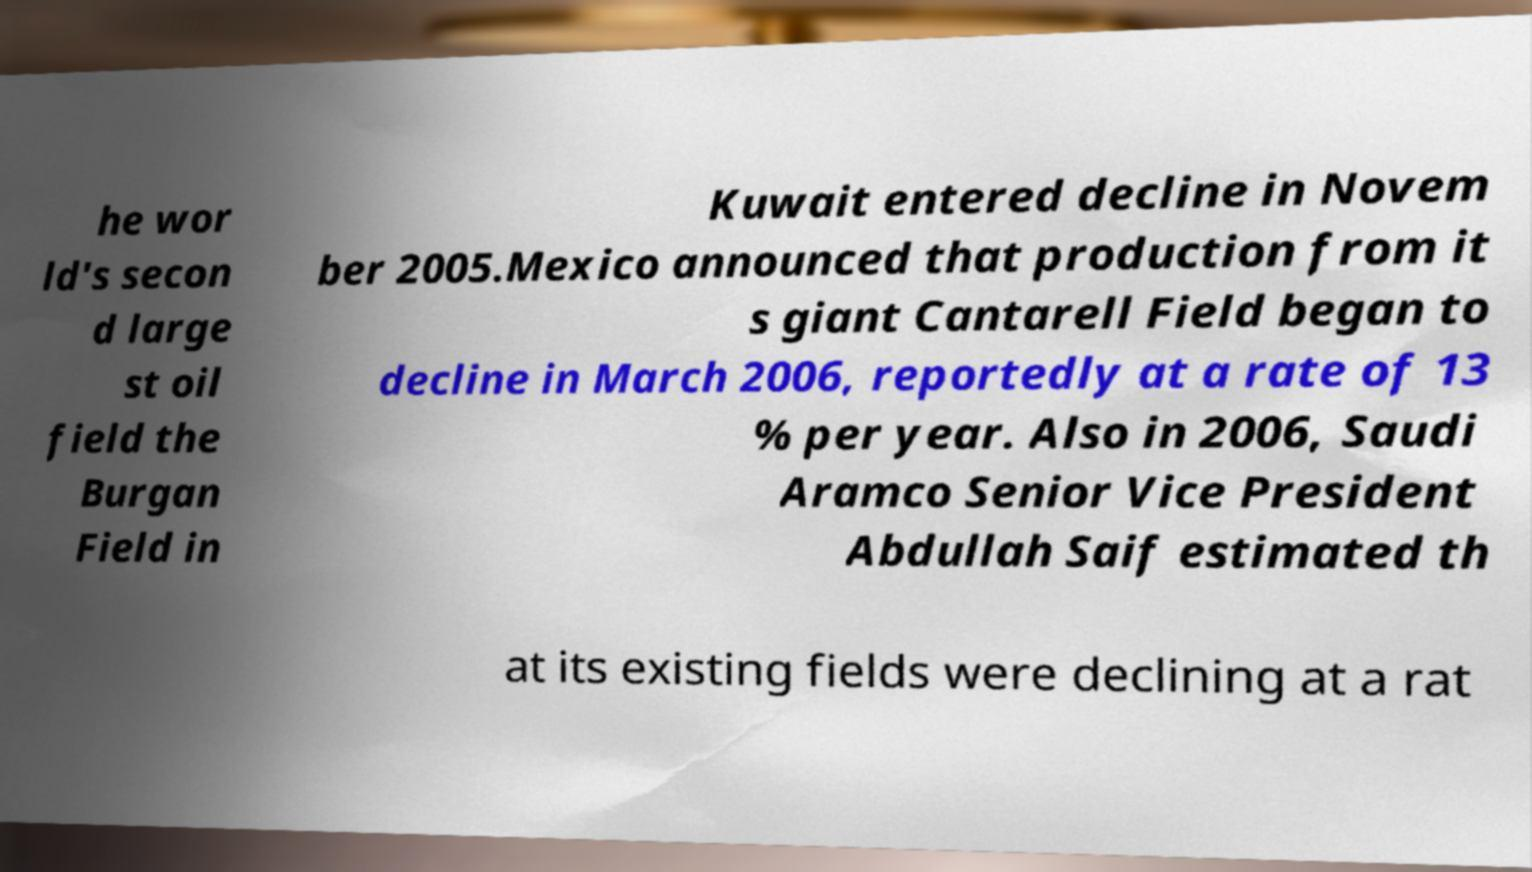There's text embedded in this image that I need extracted. Can you transcribe it verbatim? he wor ld's secon d large st oil field the Burgan Field in Kuwait entered decline in Novem ber 2005.Mexico announced that production from it s giant Cantarell Field began to decline in March 2006, reportedly at a rate of 13 % per year. Also in 2006, Saudi Aramco Senior Vice President Abdullah Saif estimated th at its existing fields were declining at a rat 